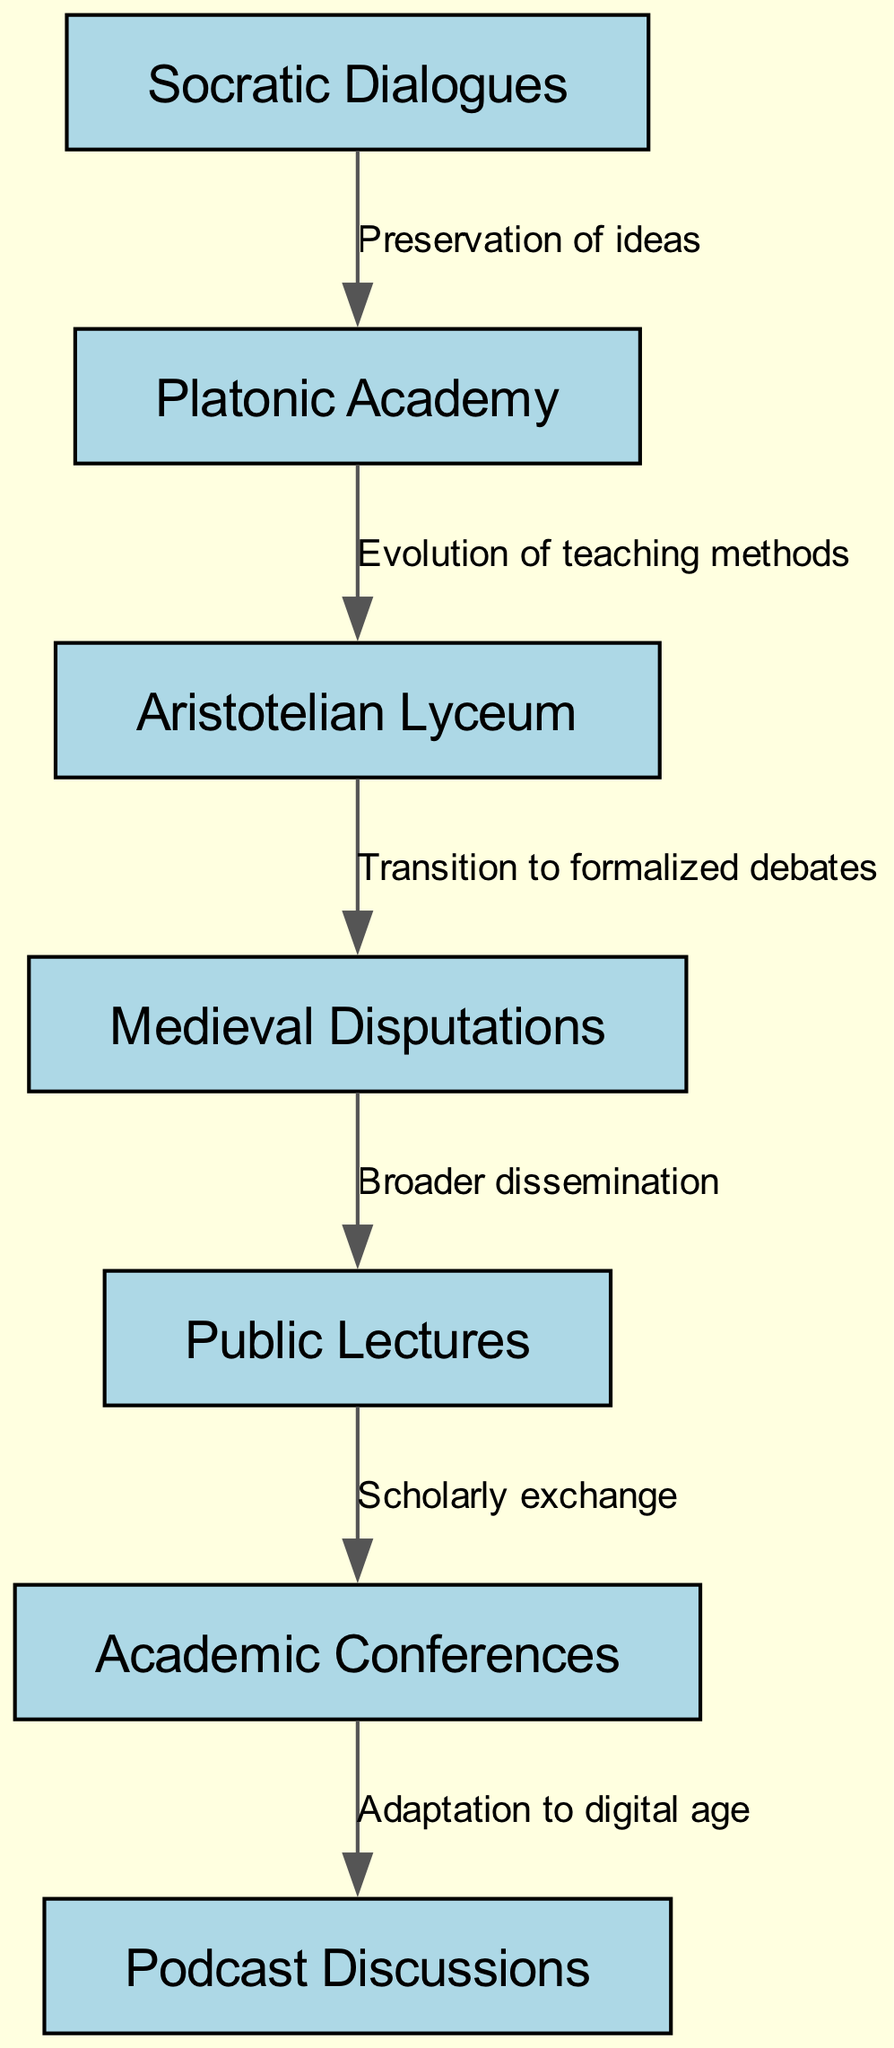What is the first node in the diagram? The first node in the diagram is identified as "Socratic Dialogues." This is determined by observing the nodes in the flow diagram from the top down.
Answer: Socratic Dialogues How many nodes are in the diagram? The total count of nodes is derived by counting all unique labeled elements within the diagram. There are seven nodes in total.
Answer: 7 What is the relationship between "Aristotelian Lyceum" and "Medieval Disputations"? The relationship is established by examining the edges connecting the nodes. The edge shows the label "Transition to formalized debates," indicating the movement from Aristotelian teachings to medieval discussions.
Answer: Transition to formalized debates Which node comes after "Public Lectures"? By following the flow of the diagram, the node that follows "Public Lectures" is "Academic Conferences." This direct connection is represented by an edge leading from one node to the next.
Answer: Academic Conferences What represents the evolution of teaching methods? The relationship labeled as "Evolution of teaching methods" connects the nodes "Platonic Academy" and "Aristotelian Lyceum," indicating this specific concept. This can be identified by looking for the associated edge and its label in the diagram.
Answer: Evolution of teaching methods Which nodes are connected in a way that leads to modern-day practices? The nodes "Academic Conferences" and "Podcast Discussions" represent the connection leading to contemporary discussions, evidenced by the last edge in the flow diagram, which indicates the adaptation of philosophies in today's digital context.
Answer: Academic Conferences, Podcast Discussions What is the final node in the diagram? The final node is identified as "Podcast Discussions," which can be found at the end of the flow, indicating the culmination of the oral tradition process as depicted in the diagram.
Answer: Podcast Discussions How many edges are present in the diagram? The total number of edges is established by counting the connections shown in the flow diagram. There are six edges connecting various nodes.
Answer: 6 Which node signifies broader dissemination? The node that indicates broader dissemination is "Public Lectures." This is found by looking for the edge leading from "Medieval Disputations," indicating a shift towards a wider audience.
Answer: Public Lectures 